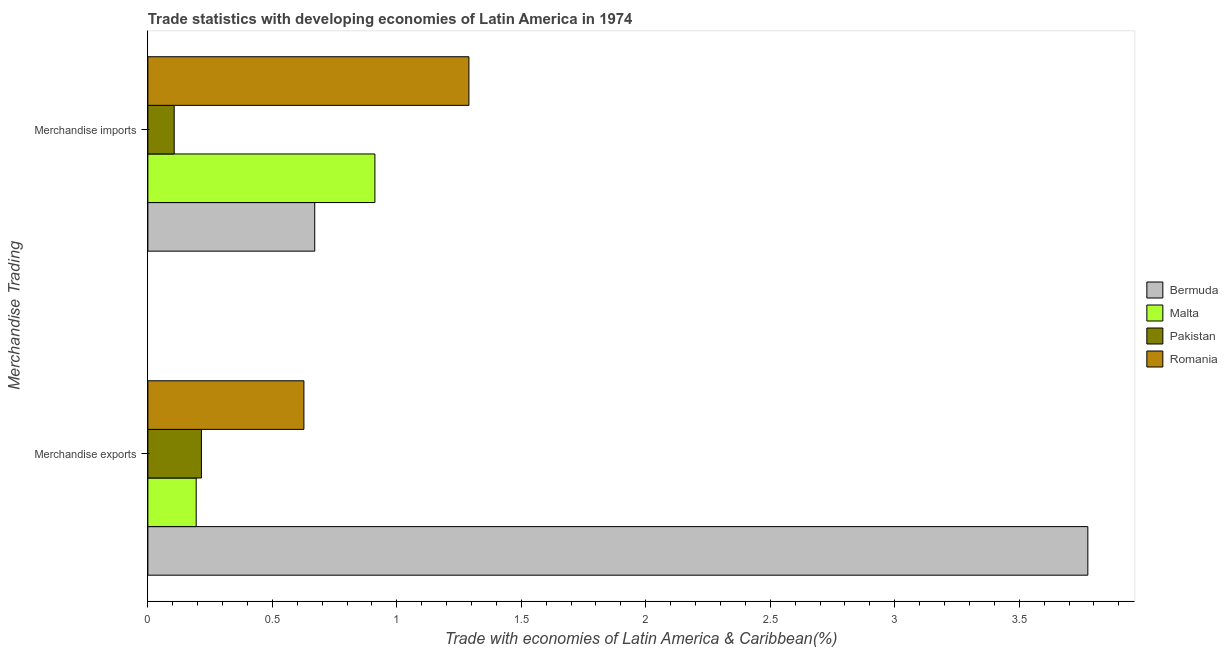How many different coloured bars are there?
Ensure brevity in your answer.  4. Are the number of bars per tick equal to the number of legend labels?
Provide a short and direct response. Yes. How many bars are there on the 1st tick from the top?
Your answer should be compact. 4. What is the merchandise imports in Romania?
Provide a succinct answer. 1.29. Across all countries, what is the maximum merchandise exports?
Your answer should be compact. 3.78. Across all countries, what is the minimum merchandise exports?
Ensure brevity in your answer.  0.19. In which country was the merchandise imports maximum?
Your answer should be very brief. Romania. In which country was the merchandise exports minimum?
Give a very brief answer. Malta. What is the total merchandise imports in the graph?
Your answer should be compact. 2.98. What is the difference between the merchandise imports in Pakistan and that in Malta?
Give a very brief answer. -0.81. What is the difference between the merchandise exports in Romania and the merchandise imports in Malta?
Offer a terse response. -0.29. What is the average merchandise imports per country?
Make the answer very short. 0.74. What is the difference between the merchandise exports and merchandise imports in Pakistan?
Keep it short and to the point. 0.11. In how many countries, is the merchandise exports greater than 3.8 %?
Make the answer very short. 0. What is the ratio of the merchandise imports in Pakistan to that in Bermuda?
Your answer should be compact. 0.16. What does the 4th bar from the top in Merchandise exports represents?
Make the answer very short. Bermuda. What does the 2nd bar from the bottom in Merchandise imports represents?
Keep it short and to the point. Malta. How many bars are there?
Keep it short and to the point. 8. Are all the bars in the graph horizontal?
Your answer should be very brief. Yes. What is the difference between two consecutive major ticks on the X-axis?
Keep it short and to the point. 0.5. Does the graph contain any zero values?
Your answer should be very brief. No. Does the graph contain grids?
Offer a very short reply. No. Where does the legend appear in the graph?
Your response must be concise. Center right. How are the legend labels stacked?
Ensure brevity in your answer.  Vertical. What is the title of the graph?
Provide a succinct answer. Trade statistics with developing economies of Latin America in 1974. What is the label or title of the X-axis?
Give a very brief answer. Trade with economies of Latin America & Caribbean(%). What is the label or title of the Y-axis?
Provide a short and direct response. Merchandise Trading. What is the Trade with economies of Latin America & Caribbean(%) in Bermuda in Merchandise exports?
Your answer should be very brief. 3.78. What is the Trade with economies of Latin America & Caribbean(%) of Malta in Merchandise exports?
Your answer should be compact. 0.19. What is the Trade with economies of Latin America & Caribbean(%) in Pakistan in Merchandise exports?
Make the answer very short. 0.22. What is the Trade with economies of Latin America & Caribbean(%) of Romania in Merchandise exports?
Your response must be concise. 0.63. What is the Trade with economies of Latin America & Caribbean(%) in Bermuda in Merchandise imports?
Your response must be concise. 0.67. What is the Trade with economies of Latin America & Caribbean(%) in Malta in Merchandise imports?
Provide a succinct answer. 0.91. What is the Trade with economies of Latin America & Caribbean(%) in Pakistan in Merchandise imports?
Keep it short and to the point. 0.11. What is the Trade with economies of Latin America & Caribbean(%) in Romania in Merchandise imports?
Keep it short and to the point. 1.29. Across all Merchandise Trading, what is the maximum Trade with economies of Latin America & Caribbean(%) in Bermuda?
Your answer should be very brief. 3.78. Across all Merchandise Trading, what is the maximum Trade with economies of Latin America & Caribbean(%) of Malta?
Provide a short and direct response. 0.91. Across all Merchandise Trading, what is the maximum Trade with economies of Latin America & Caribbean(%) of Pakistan?
Give a very brief answer. 0.22. Across all Merchandise Trading, what is the maximum Trade with economies of Latin America & Caribbean(%) of Romania?
Provide a short and direct response. 1.29. Across all Merchandise Trading, what is the minimum Trade with economies of Latin America & Caribbean(%) in Bermuda?
Provide a succinct answer. 0.67. Across all Merchandise Trading, what is the minimum Trade with economies of Latin America & Caribbean(%) in Malta?
Your answer should be very brief. 0.19. Across all Merchandise Trading, what is the minimum Trade with economies of Latin America & Caribbean(%) in Pakistan?
Provide a succinct answer. 0.11. Across all Merchandise Trading, what is the minimum Trade with economies of Latin America & Caribbean(%) of Romania?
Offer a terse response. 0.63. What is the total Trade with economies of Latin America & Caribbean(%) in Bermuda in the graph?
Offer a terse response. 4.45. What is the total Trade with economies of Latin America & Caribbean(%) of Malta in the graph?
Your response must be concise. 1.11. What is the total Trade with economies of Latin America & Caribbean(%) in Pakistan in the graph?
Your answer should be compact. 0.32. What is the total Trade with economies of Latin America & Caribbean(%) of Romania in the graph?
Your answer should be compact. 1.92. What is the difference between the Trade with economies of Latin America & Caribbean(%) of Bermuda in Merchandise exports and that in Merchandise imports?
Offer a very short reply. 3.11. What is the difference between the Trade with economies of Latin America & Caribbean(%) in Malta in Merchandise exports and that in Merchandise imports?
Keep it short and to the point. -0.72. What is the difference between the Trade with economies of Latin America & Caribbean(%) in Pakistan in Merchandise exports and that in Merchandise imports?
Your answer should be very brief. 0.11. What is the difference between the Trade with economies of Latin America & Caribbean(%) in Romania in Merchandise exports and that in Merchandise imports?
Keep it short and to the point. -0.66. What is the difference between the Trade with economies of Latin America & Caribbean(%) of Bermuda in Merchandise exports and the Trade with economies of Latin America & Caribbean(%) of Malta in Merchandise imports?
Provide a succinct answer. 2.86. What is the difference between the Trade with economies of Latin America & Caribbean(%) in Bermuda in Merchandise exports and the Trade with economies of Latin America & Caribbean(%) in Pakistan in Merchandise imports?
Ensure brevity in your answer.  3.67. What is the difference between the Trade with economies of Latin America & Caribbean(%) in Bermuda in Merchandise exports and the Trade with economies of Latin America & Caribbean(%) in Romania in Merchandise imports?
Provide a succinct answer. 2.49. What is the difference between the Trade with economies of Latin America & Caribbean(%) of Malta in Merchandise exports and the Trade with economies of Latin America & Caribbean(%) of Pakistan in Merchandise imports?
Provide a succinct answer. 0.09. What is the difference between the Trade with economies of Latin America & Caribbean(%) of Malta in Merchandise exports and the Trade with economies of Latin America & Caribbean(%) of Romania in Merchandise imports?
Keep it short and to the point. -1.1. What is the difference between the Trade with economies of Latin America & Caribbean(%) of Pakistan in Merchandise exports and the Trade with economies of Latin America & Caribbean(%) of Romania in Merchandise imports?
Provide a short and direct response. -1.07. What is the average Trade with economies of Latin America & Caribbean(%) of Bermuda per Merchandise Trading?
Your answer should be very brief. 2.22. What is the average Trade with economies of Latin America & Caribbean(%) of Malta per Merchandise Trading?
Keep it short and to the point. 0.55. What is the average Trade with economies of Latin America & Caribbean(%) in Pakistan per Merchandise Trading?
Provide a short and direct response. 0.16. What is the average Trade with economies of Latin America & Caribbean(%) of Romania per Merchandise Trading?
Ensure brevity in your answer.  0.96. What is the difference between the Trade with economies of Latin America & Caribbean(%) in Bermuda and Trade with economies of Latin America & Caribbean(%) in Malta in Merchandise exports?
Your answer should be very brief. 3.58. What is the difference between the Trade with economies of Latin America & Caribbean(%) in Bermuda and Trade with economies of Latin America & Caribbean(%) in Pakistan in Merchandise exports?
Offer a very short reply. 3.56. What is the difference between the Trade with economies of Latin America & Caribbean(%) of Bermuda and Trade with economies of Latin America & Caribbean(%) of Romania in Merchandise exports?
Ensure brevity in your answer.  3.15. What is the difference between the Trade with economies of Latin America & Caribbean(%) in Malta and Trade with economies of Latin America & Caribbean(%) in Pakistan in Merchandise exports?
Your response must be concise. -0.02. What is the difference between the Trade with economies of Latin America & Caribbean(%) of Malta and Trade with economies of Latin America & Caribbean(%) of Romania in Merchandise exports?
Your response must be concise. -0.43. What is the difference between the Trade with economies of Latin America & Caribbean(%) in Pakistan and Trade with economies of Latin America & Caribbean(%) in Romania in Merchandise exports?
Your response must be concise. -0.41. What is the difference between the Trade with economies of Latin America & Caribbean(%) of Bermuda and Trade with economies of Latin America & Caribbean(%) of Malta in Merchandise imports?
Offer a very short reply. -0.24. What is the difference between the Trade with economies of Latin America & Caribbean(%) in Bermuda and Trade with economies of Latin America & Caribbean(%) in Pakistan in Merchandise imports?
Keep it short and to the point. 0.56. What is the difference between the Trade with economies of Latin America & Caribbean(%) of Bermuda and Trade with economies of Latin America & Caribbean(%) of Romania in Merchandise imports?
Offer a very short reply. -0.62. What is the difference between the Trade with economies of Latin America & Caribbean(%) of Malta and Trade with economies of Latin America & Caribbean(%) of Pakistan in Merchandise imports?
Your response must be concise. 0.81. What is the difference between the Trade with economies of Latin America & Caribbean(%) in Malta and Trade with economies of Latin America & Caribbean(%) in Romania in Merchandise imports?
Ensure brevity in your answer.  -0.38. What is the difference between the Trade with economies of Latin America & Caribbean(%) of Pakistan and Trade with economies of Latin America & Caribbean(%) of Romania in Merchandise imports?
Offer a very short reply. -1.18. What is the ratio of the Trade with economies of Latin America & Caribbean(%) in Bermuda in Merchandise exports to that in Merchandise imports?
Your answer should be compact. 5.63. What is the ratio of the Trade with economies of Latin America & Caribbean(%) of Malta in Merchandise exports to that in Merchandise imports?
Offer a terse response. 0.21. What is the ratio of the Trade with economies of Latin America & Caribbean(%) of Pakistan in Merchandise exports to that in Merchandise imports?
Keep it short and to the point. 2.03. What is the ratio of the Trade with economies of Latin America & Caribbean(%) in Romania in Merchandise exports to that in Merchandise imports?
Your answer should be very brief. 0.49. What is the difference between the highest and the second highest Trade with economies of Latin America & Caribbean(%) in Bermuda?
Ensure brevity in your answer.  3.11. What is the difference between the highest and the second highest Trade with economies of Latin America & Caribbean(%) of Malta?
Your answer should be very brief. 0.72. What is the difference between the highest and the second highest Trade with economies of Latin America & Caribbean(%) of Pakistan?
Provide a short and direct response. 0.11. What is the difference between the highest and the second highest Trade with economies of Latin America & Caribbean(%) in Romania?
Keep it short and to the point. 0.66. What is the difference between the highest and the lowest Trade with economies of Latin America & Caribbean(%) in Bermuda?
Offer a very short reply. 3.11. What is the difference between the highest and the lowest Trade with economies of Latin America & Caribbean(%) in Malta?
Your answer should be very brief. 0.72. What is the difference between the highest and the lowest Trade with economies of Latin America & Caribbean(%) in Pakistan?
Make the answer very short. 0.11. What is the difference between the highest and the lowest Trade with economies of Latin America & Caribbean(%) in Romania?
Your response must be concise. 0.66. 